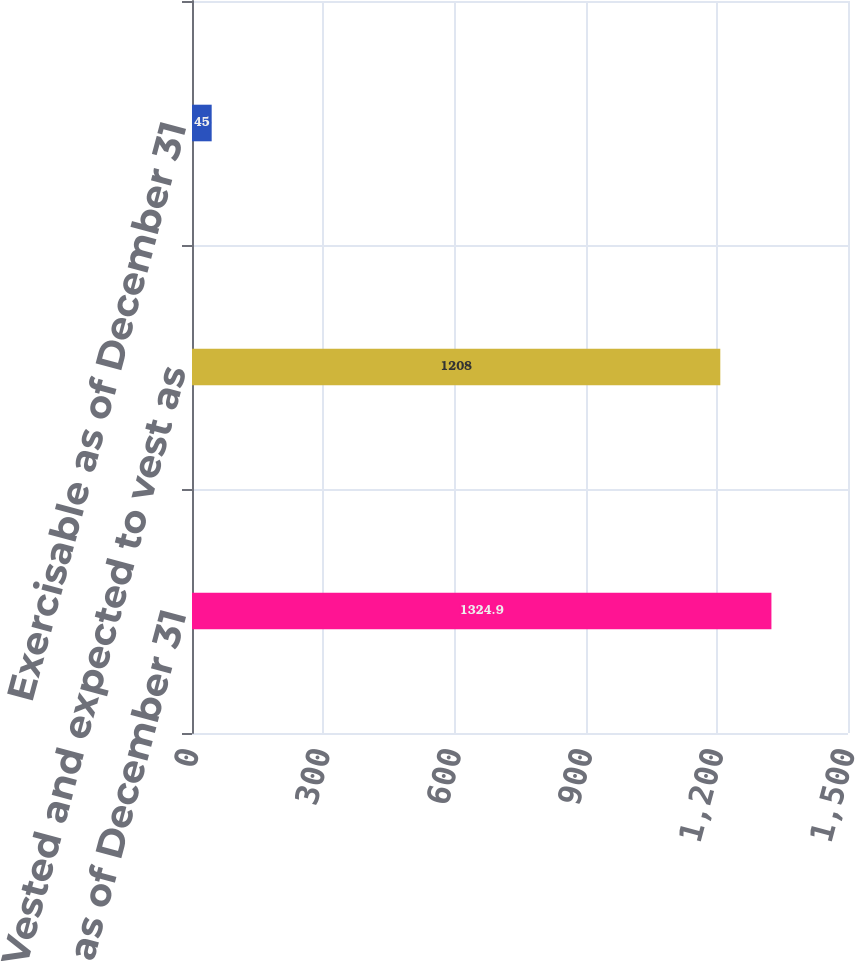<chart> <loc_0><loc_0><loc_500><loc_500><bar_chart><fcel>Outstanding as of December 31<fcel>Vested and expected to vest as<fcel>Exercisable as of December 31<nl><fcel>1324.9<fcel>1208<fcel>45<nl></chart> 